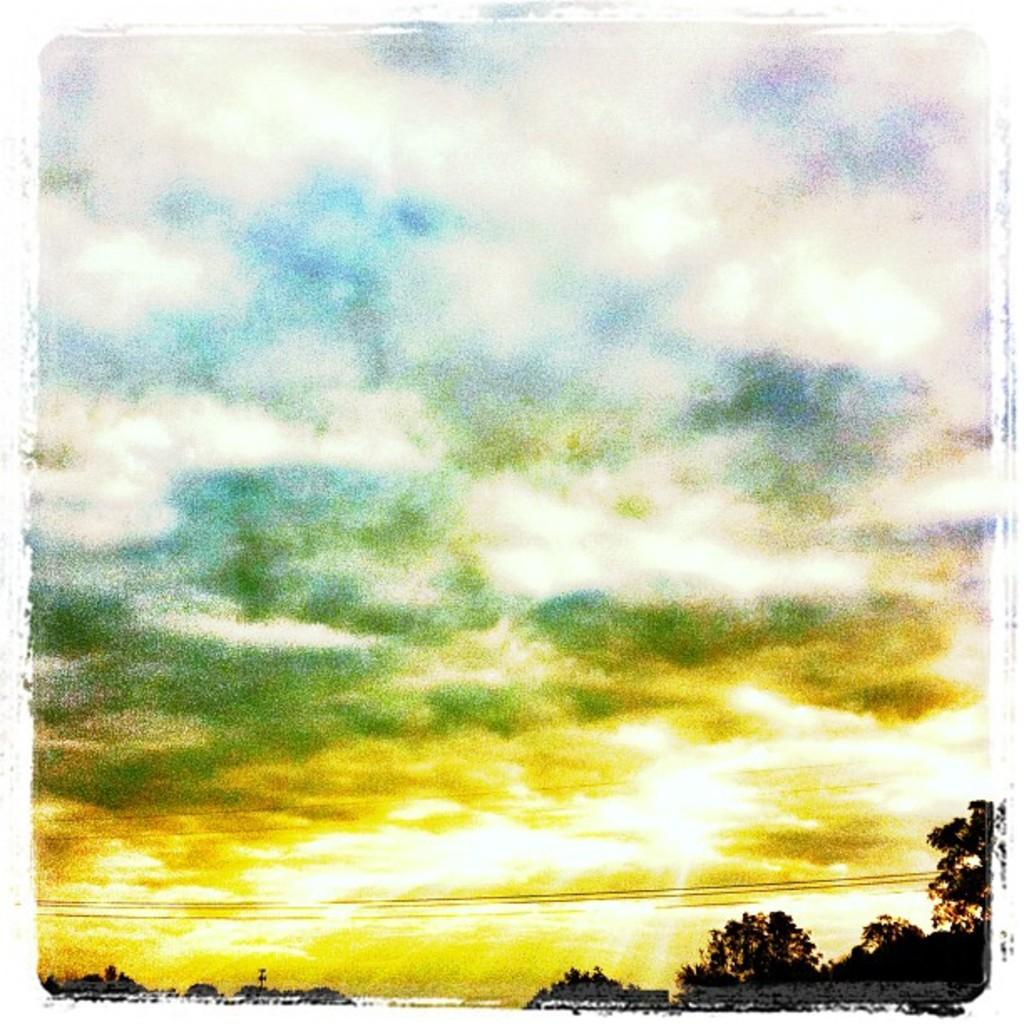What type of natural elements can be seen in the image? There are trees in the image. What man-made objects are present in the image? There are cables in the image. What can be seen in the sky in the image? There are clouds visible in the image. What type of cap is the tree wearing in the image? There is no cap present on the tree in the image. How does the health of the clouds in the image affect the trees? The health of the clouds does not affect the trees in the image, as clouds are not living organisms and cannot impact the health of trees. 